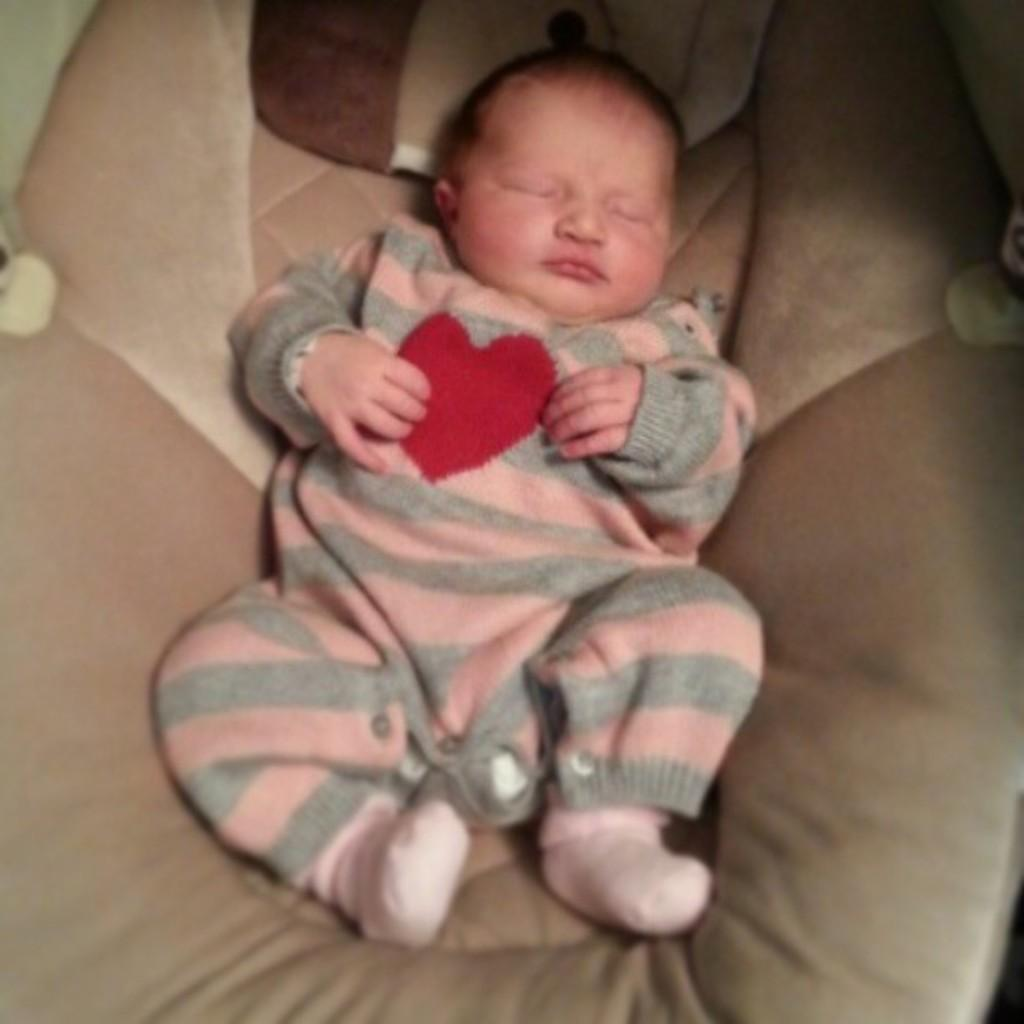What is the main subject of the image? There is a baby in the image. What is the baby doing in the image? The baby is sleeping. Where is the baby located in the image? The baby is on a baby couch. What type of dirt can be seen on the baby's clothes in the image? There is no dirt visible on the baby's clothes in the image. How does the cat interact with the baby in the image? There is no cat present in the image. 